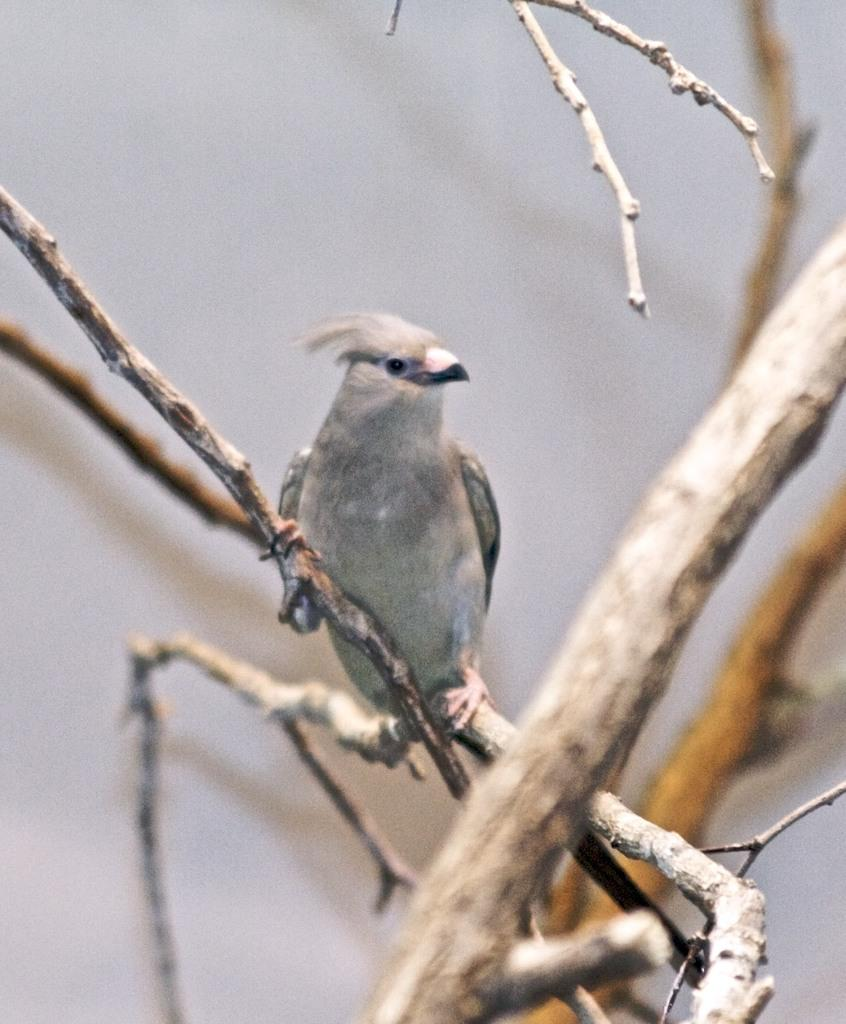What type of bird can be seen in the image? There is a grey color bird in the image. What is the bird standing on? The bird is standing on a dried tree. What is the name of the bird in the image? The provided facts do not mention the name of the bird, so we cannot determine its name from the image. 